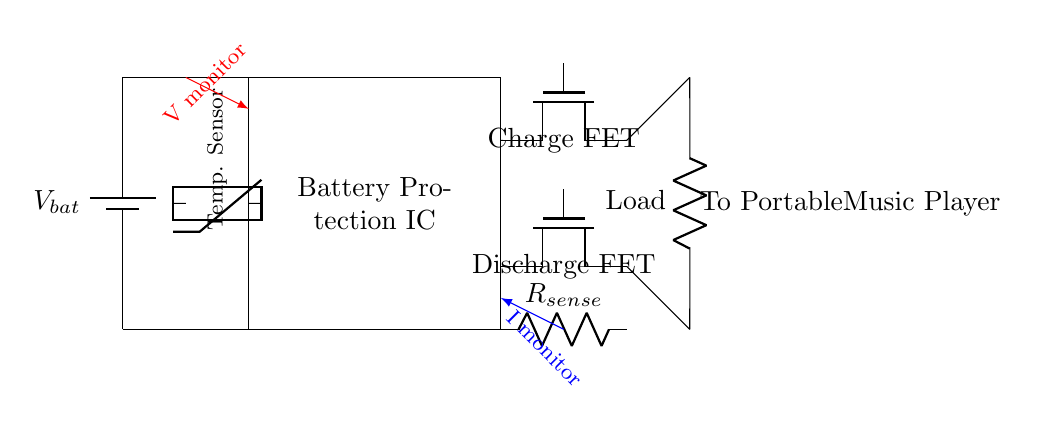What type of battery is used in this circuit? The circuit shows a battery symbol labeled as V_bat, indicating it is a general battery type, commonly a lithium-ion battery for portable applications.
Answer: battery What does the Battery Protection IC do? The Battery Protection IC is responsible for monitoring and managing the battery's charging and discharging processes to prevent overcharging and excessive discharging.
Answer: Battery Protection IC How many MOSFET switches are present in the circuit? There are two MOSFET switches indicated: a Charge FET and a Discharge FET, each serving different roles in controlling the battery's charge and discharge paths.
Answer: two What is the function of the current sense resistor? The current sense resistor, labeled as R_sense, is used to monitor the current flowing through the circuit, allowing for detection of overcurrent conditions.
Answer: monitor current What do the monitoring signals indicate in this circuit? The circuit includes two monitoring signals: V monitor for voltage and I monitor for current, used for monitoring battery conditions to prevent damage from abnormal conditions.
Answer: voltage and current monitoring Why is there a temperature sensor in the circuit? The temperature sensor ensures that the battery operates within safe temperature limits, protecting against overheating that could lead to battery failure or hazards.
Answer: to monitor temperature 